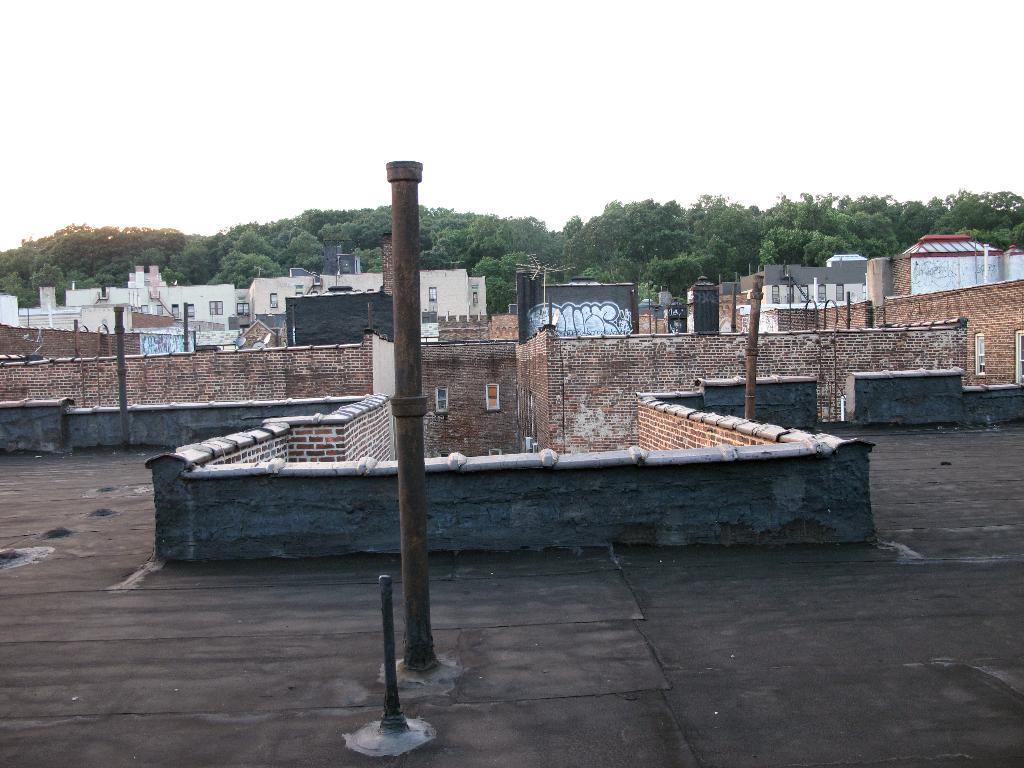What type of structures can be seen in the image? There are buildings in the image. What else can be seen in the image besides buildings? There are poles and trees in the image. What is the condition of the sky in the image? The sky is cloudy in the image. What is the opinion of the toad about the airport in the image? There is no toad or airport present in the image, so it is not possible to determine any opinions. 